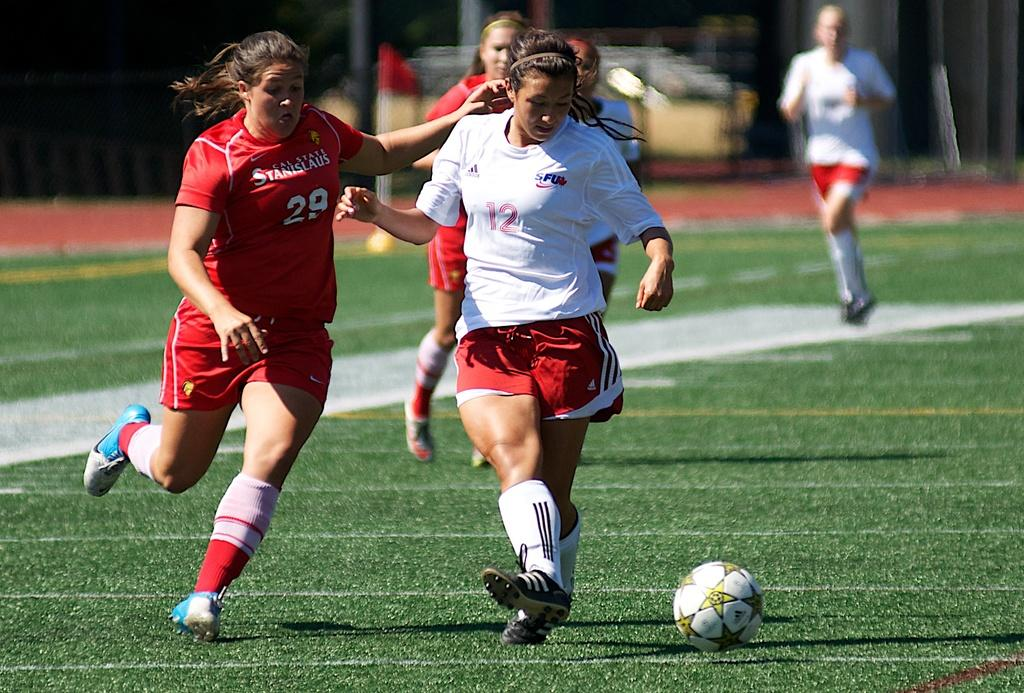<image>
Summarize the visual content of the image. A girl is playing soccer with the number 12 on her shirt. 